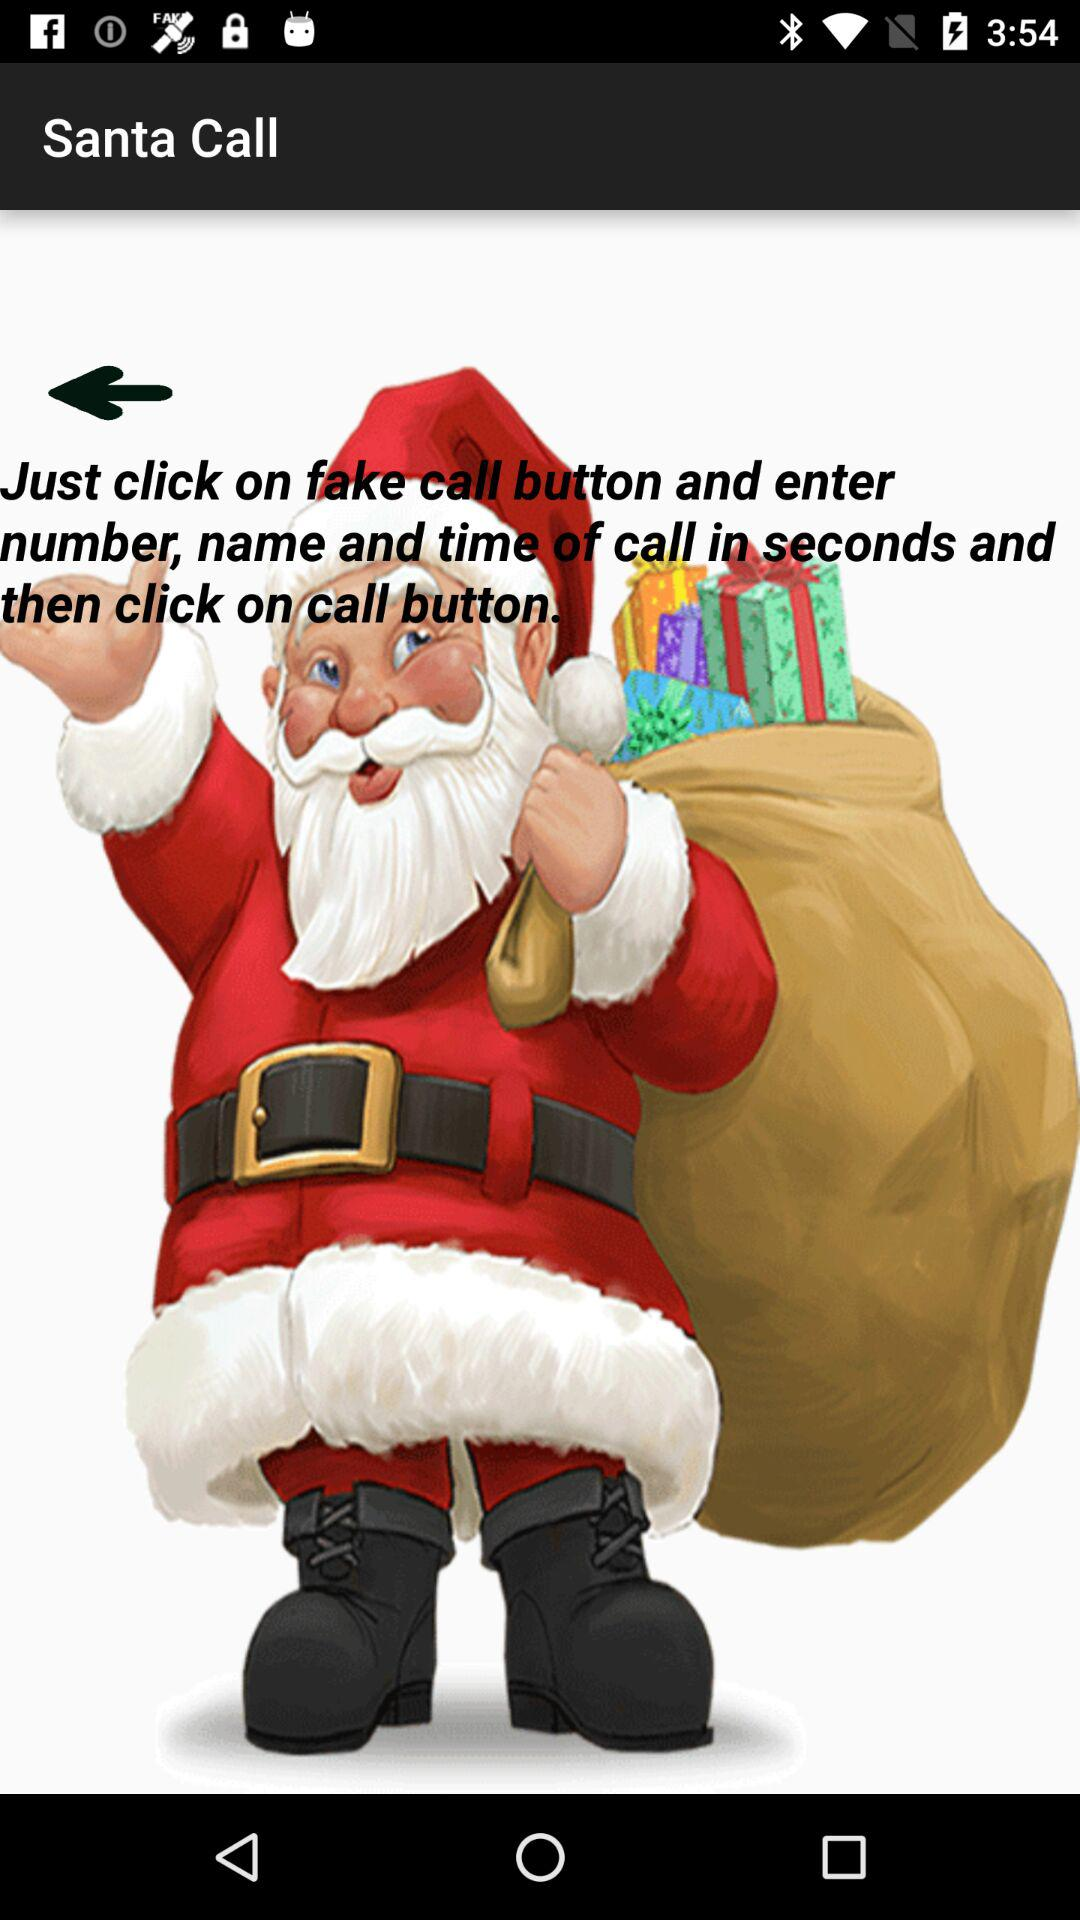How to call Santa? To call Santa, "Just click on fake call button and enter number, name and time of call in seconds and then click on call button.". 